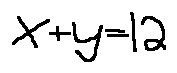Convert formula to latex. <formula><loc_0><loc_0><loc_500><loc_500>x + y = 1 2</formula> 